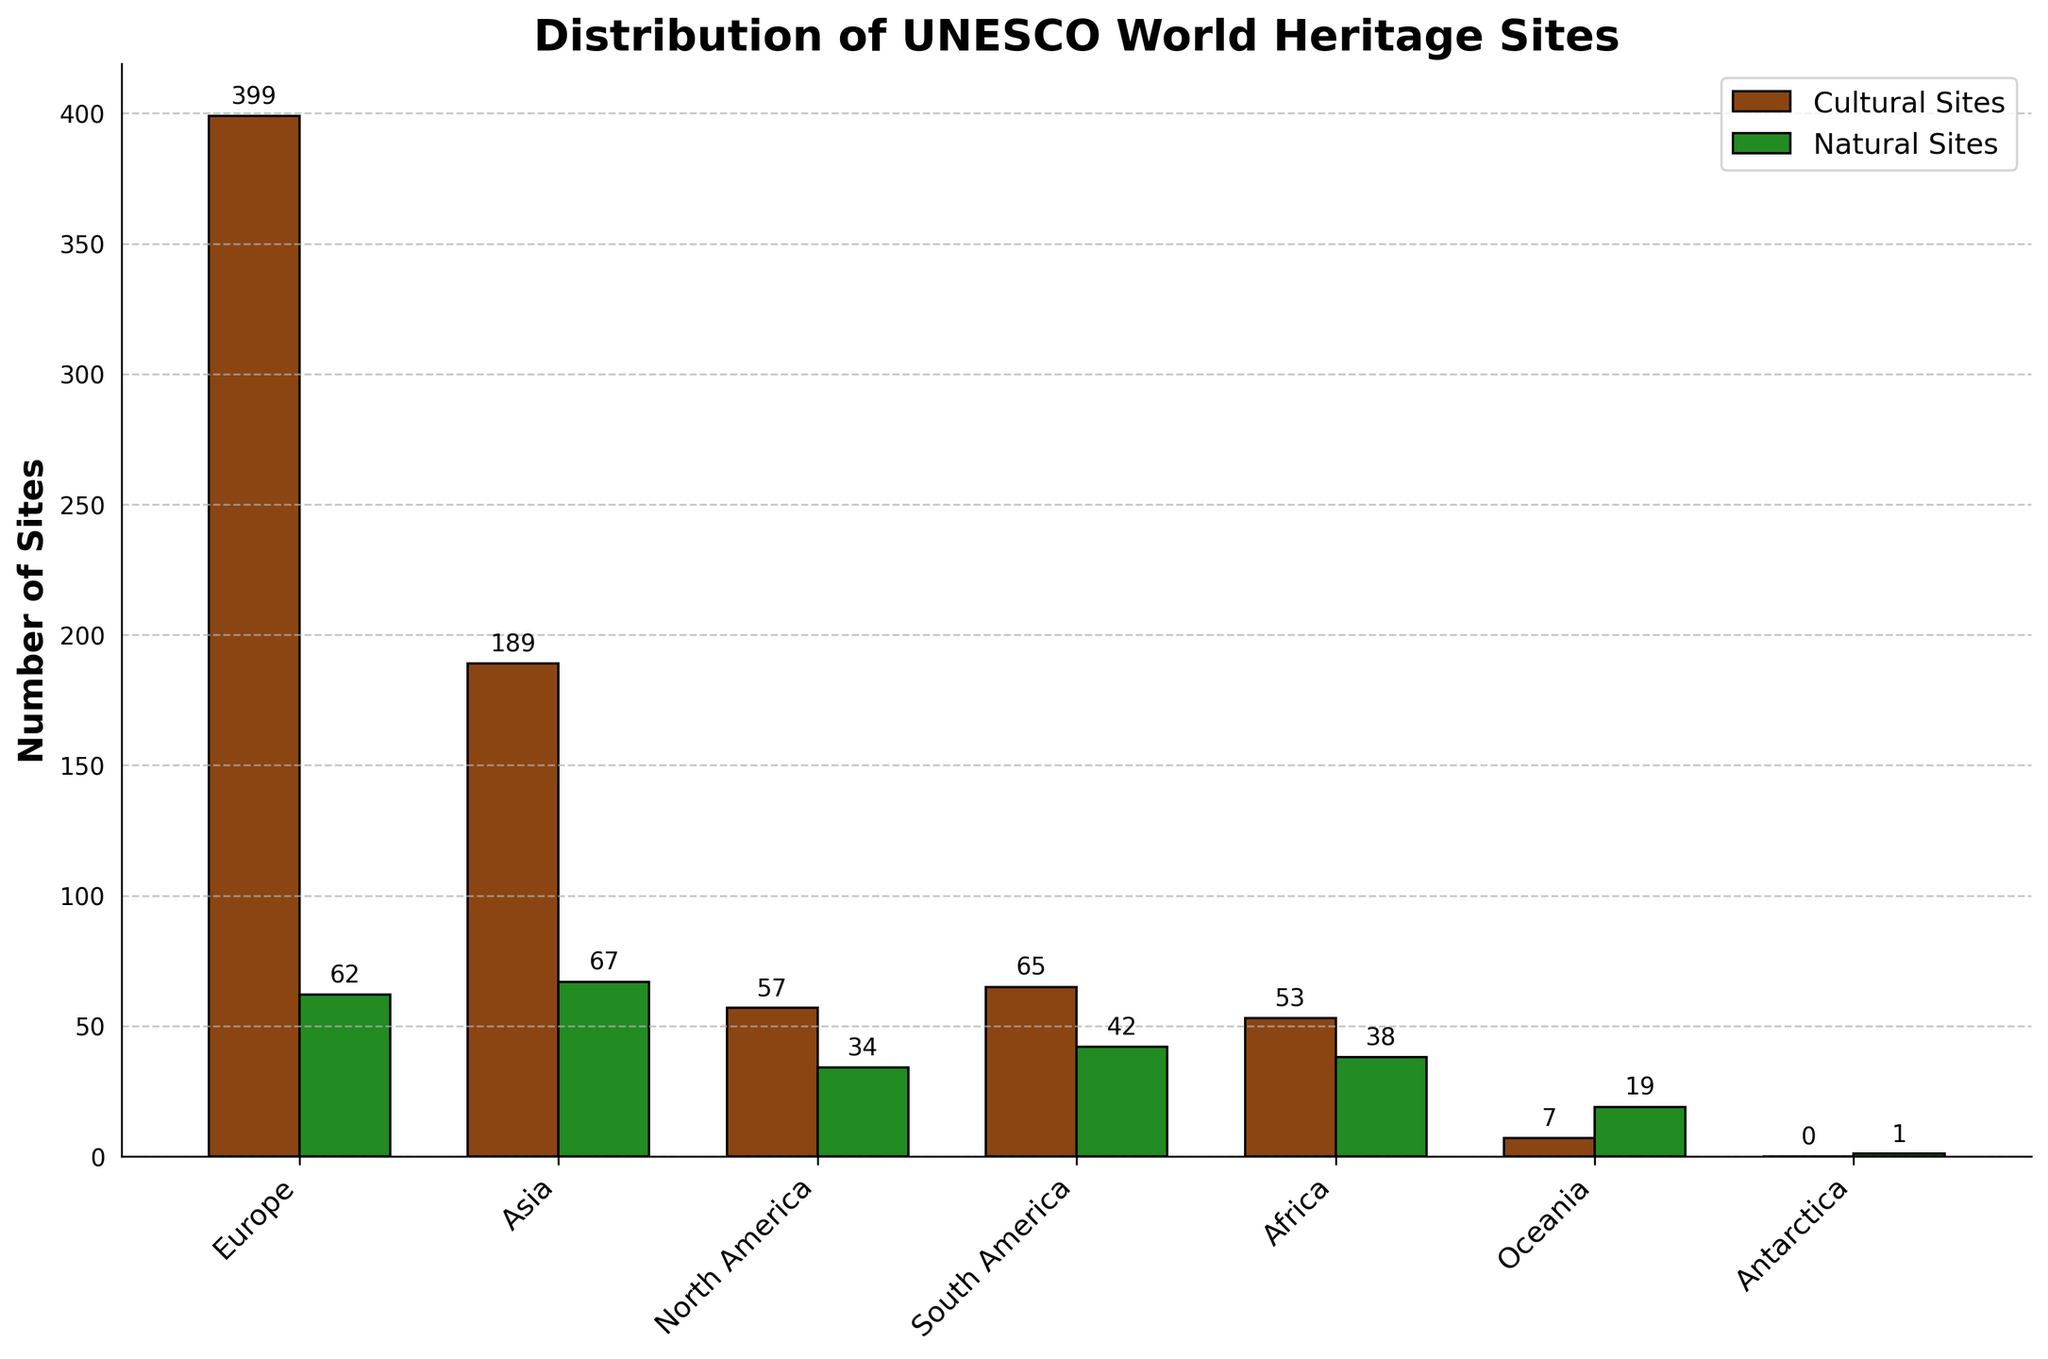Which continent has the highest number of cultural sites? By observing the bars representing cultural sites, the bar for Europe is the tallest.
Answer: Europe Which continent has more natural sites: Africa or South America? By comparing the heights of the bars for natural sites for Africa and South America, we see that South America has a slightly taller bar than Africa.
Answer: South America What is the total number of UNESCO World Heritage Sites in North America? Add the numbers for cultural sites (57) and natural sites (34) in North America: 57 + 34 = 91.
Answer: 91 Which has more UNESCO World Heritage Sites overall, Asia or South America? Sum the cultural and natural sites for each continent: Asia (189 + 67 = 256) and South America (65 + 42 = 107). Asia has more.
Answer: Asia What is the difference in the number of cultural sites between Europe and Asia? Subtract the number of cultural sites in Asia (189) from the number in Europe (399): 399 - 189 = 210.
Answer: 210 Which continent has the fewest cultural sites? By observing the bars representing cultural sites, Oceania has the shortest bar.
Answer: Oceania Considering only natural sites, which continent is closest to Europe in number? By comparing the heights of the bars for natural sites, Asia with 67 is closest to Europe's 62.
Answer: Asia What is the combined number of natural sites in Africa and Oceania? Add the natural sites in Africa (38) to those in Oceania (19): 38 + 19 = 57.
Answer: 57 How many more cultural sites does South America have compared to Africa? Subtract the number of cultural sites in Africa (53) from the number in South America (65): 65 - 53 = 12.
Answer: 12 Which continent has exactly one natural site? By observing the bars for natural sites, Antarctica has one site.
Answer: Antarctica 